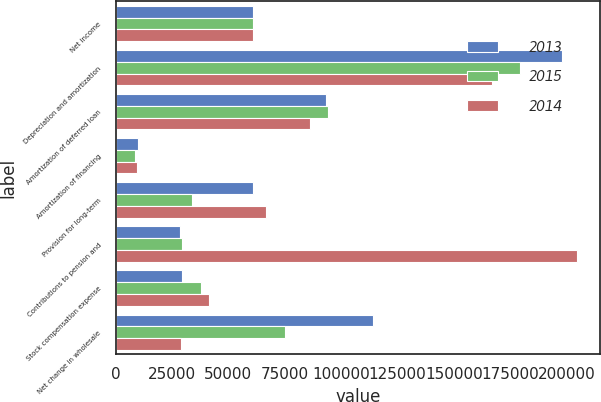Convert chart to OTSL. <chart><loc_0><loc_0><loc_500><loc_500><stacked_bar_chart><ecel><fcel>Net income<fcel>Depreciation and amortization<fcel>Amortization of deferred loan<fcel>Amortization of financing<fcel>Provision for long-term<fcel>Contributions to pension and<fcel>Stock compensation expense<fcel>Net change in wholesale<nl><fcel>2013<fcel>60824<fcel>198074<fcel>93546<fcel>9975<fcel>60824<fcel>28490<fcel>29433<fcel>113970<nl><fcel>2015<fcel>60824<fcel>179300<fcel>94429<fcel>8442<fcel>33709<fcel>29686<fcel>37929<fcel>75210<nl><fcel>2014<fcel>60824<fcel>167072<fcel>86181<fcel>9376<fcel>66877<fcel>204796<fcel>41244<fcel>28865<nl></chart> 